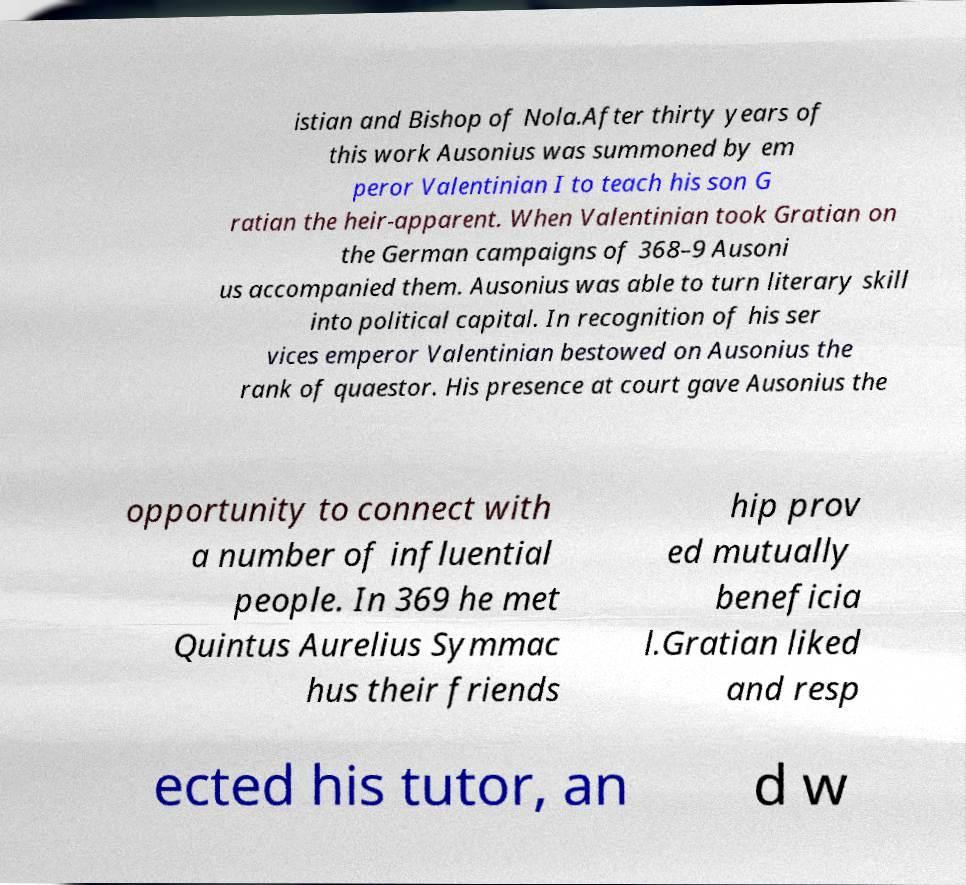For documentation purposes, I need the text within this image transcribed. Could you provide that? istian and Bishop of Nola.After thirty years of this work Ausonius was summoned by em peror Valentinian I to teach his son G ratian the heir-apparent. When Valentinian took Gratian on the German campaigns of 368–9 Ausoni us accompanied them. Ausonius was able to turn literary skill into political capital. In recognition of his ser vices emperor Valentinian bestowed on Ausonius the rank of quaestor. His presence at court gave Ausonius the opportunity to connect with a number of influential people. In 369 he met Quintus Aurelius Symmac hus their friends hip prov ed mutually beneficia l.Gratian liked and resp ected his tutor, an d w 